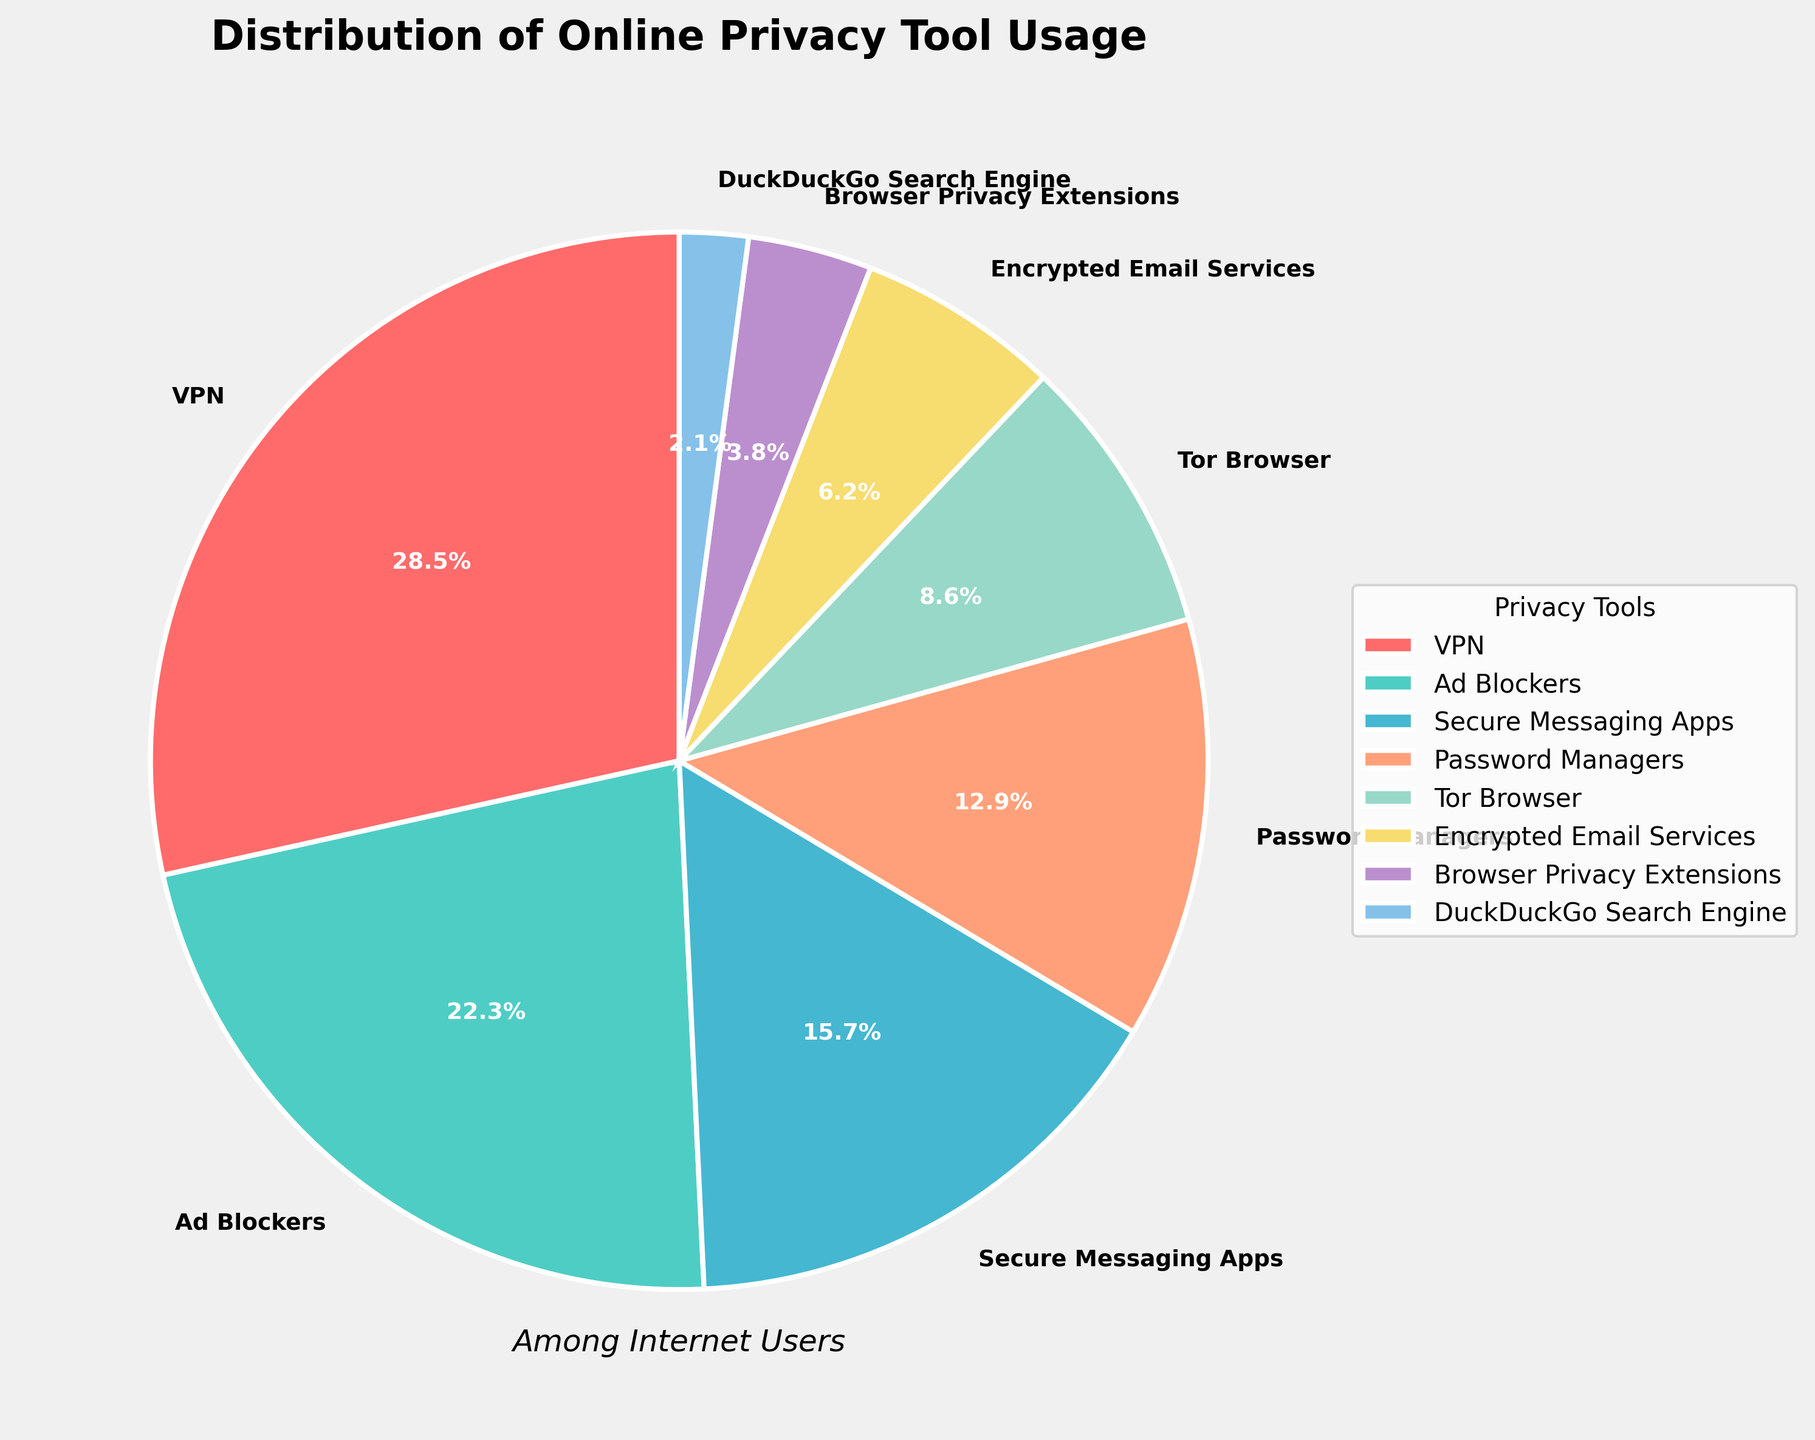What percentage of internet users use VPNs? The figure shows the distribution of online privacy tool usage. Looking at the pie chart, we can identify that 28.5% of internet users utilize VPNs.
Answer: 28.5% Which tool is used more, Ad Blockers or Password Managers? By comparing the slices of the pie chart, we can see that Ad Blockers have a larger percentage (22.3%) than Password Managers (12.9%).
Answer: Ad Blockers What is the sum of the percentages for Secure Messaging Apps and Tor Browser? The figure indicates that Secure Messaging Apps account for 15.7% and Tor Browser accounts for 8.6%. Adding these together, we get 15.7% + 8.6% = 24.3%.
Answer: 24.3% Which tool has the smallest user percentage, and what is that percentage? Reviewing the pie chart, we see that the DuckDuckGo Search Engine has the smallest slice, with a percentage of 2.1%.
Answer: DuckDuckGo Search Engine, 2.1% Are there more users of Browser Privacy Extensions or Encrypted Email Services? Comparing the slices, Browser Privacy Extensions have 3.8% while Encrypted Email Services have 6.2%. Therefore, Encrypted Email Services have more users.
Answer: Encrypted Email Services What is the difference in user percentage between VPNs and Ad Blockers? The figure shows that VPNs are used by 28.5% while Ad Blockers by 22.3%. The difference is 28.5% - 22.3% = 6.2%.
Answer: 6.2% Which two tools have the highest combined percentage usage? To find this, we sum the percentages of different combinations. The combination of VPNs (28.5%) and Ad Blockers (22.3%) gives the highest total of 28.5% + 22.3% = 50.8%.
Answer: VPNs and Ad Blockers Identify two tools with the closest percentage usage and state their percentages. Examining the chart, Browser Privacy Extensions (3.8%) and DuckDuckGo Search Engine (2.1%) have a close percentage usage, with a difference of 1.7%.
Answer: Browser Privacy Extensions (3.8%) and DuckDuckGo Search Engine (2.1%) What percentage of users use tools other than VPNs and Ad Blockers? To find this, we first sum the percentages of all tools (100%), then subtract the percentage of users using VPNs (28.5%) and Ad Blockers (22.3%). Therefore, 100% - 28.5% - 22.3% = 49.2%.
Answer: 49.2% 